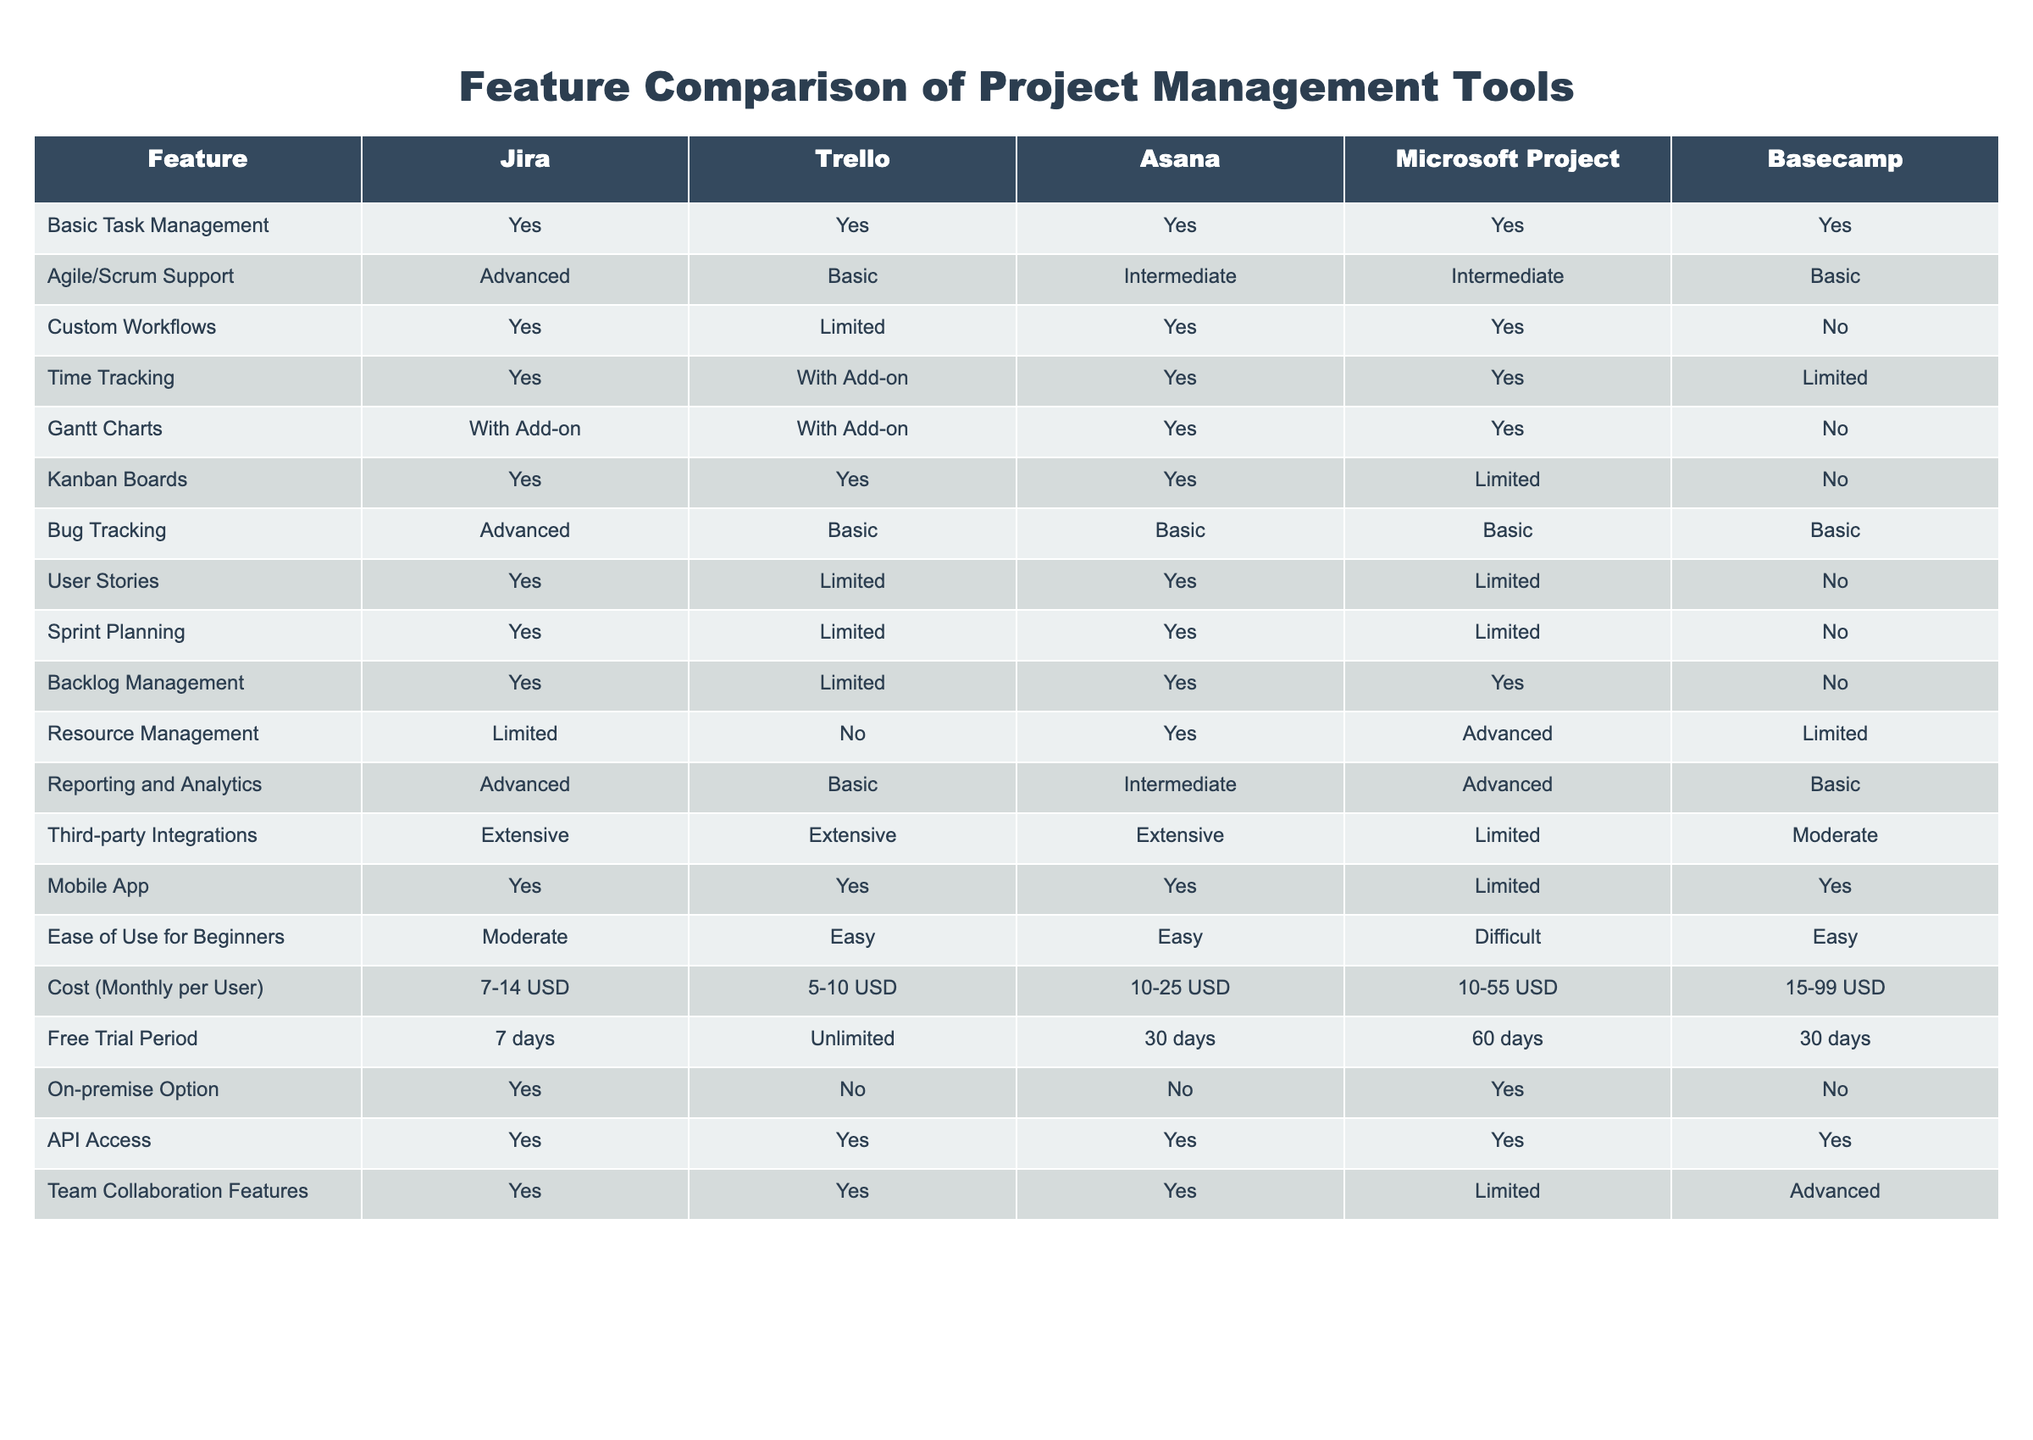What project management tool has the most extensive third-party integrations? Upon reviewing the "Third-party Integrations" column, all tools except Microsoft Project are classified as "Extensive." Therefore, Jira, Trello, and Asana each have extensive integrations, which means there is no single tool that stands out but rather three tools have equal standing.
Answer: Jira, Trello, Asana Which tool provides advanced bug tracking capabilities? Looking at the "Bug Tracking" column, we see that only Jira is classified as "Advanced." All other tools provide basic support, so Jira is the only one with advanced capabilities in this area.
Answer: Jira Is Microsoft Project the only tool that supports resource management at an advanced level? In the "Resource Management" column, it shows that Microsoft Project is classified as "Advanced," while Asana provides "Yes" and Jira and Basecamp are "Limited." Since it is not the only one offering support, but it is the only one at the advanced level, the answer is no.
Answer: No What is the average cost of the monthly subscription for the tools listed? The monthly costs per user are: Jira (7-14 USD), Trello (5-10 USD), Asana (10-25 USD), Microsoft Project (10-55 USD), and Basecamp (15-99 USD). Calculating the average requires converting ranges to a midpoint: Jira (10.5), Trello (7.5), Asana (17.5), Microsoft Project (32.5), Basecamp (57). The sum is 125, and since there are 5 tools, the average cost is 125/5 = 25 USD.
Answer: 25 USD Which tool has the longest free trial period? In the "Free Trial Period" column, Trello offers an "Unlimited" trial period, while the others range from 7 to 60 days. Thus, Trello provides the longest trial period by far.
Answer: Trello How many tools offer advanced sprint planning capabilities? Checking the "Sprint Planning" column, it indicates that Jira and Asana are marked as "Yes," while the others have a "Limited" or "No" classification. Therefore, a total of 2 tools provide advanced sprint planning capabilities.
Answer: 2 Does Basecamp offer API access? Referring to the "API Access" column, Basecamp is noted as "Yes," confirming that it does provide API access.
Answer: Yes Is there an on-premise option available for Trello? The "On-premise Option" column shows Trello is listed as "No," which indicates that Trello does not have an on-premise solution available.
Answer: No 